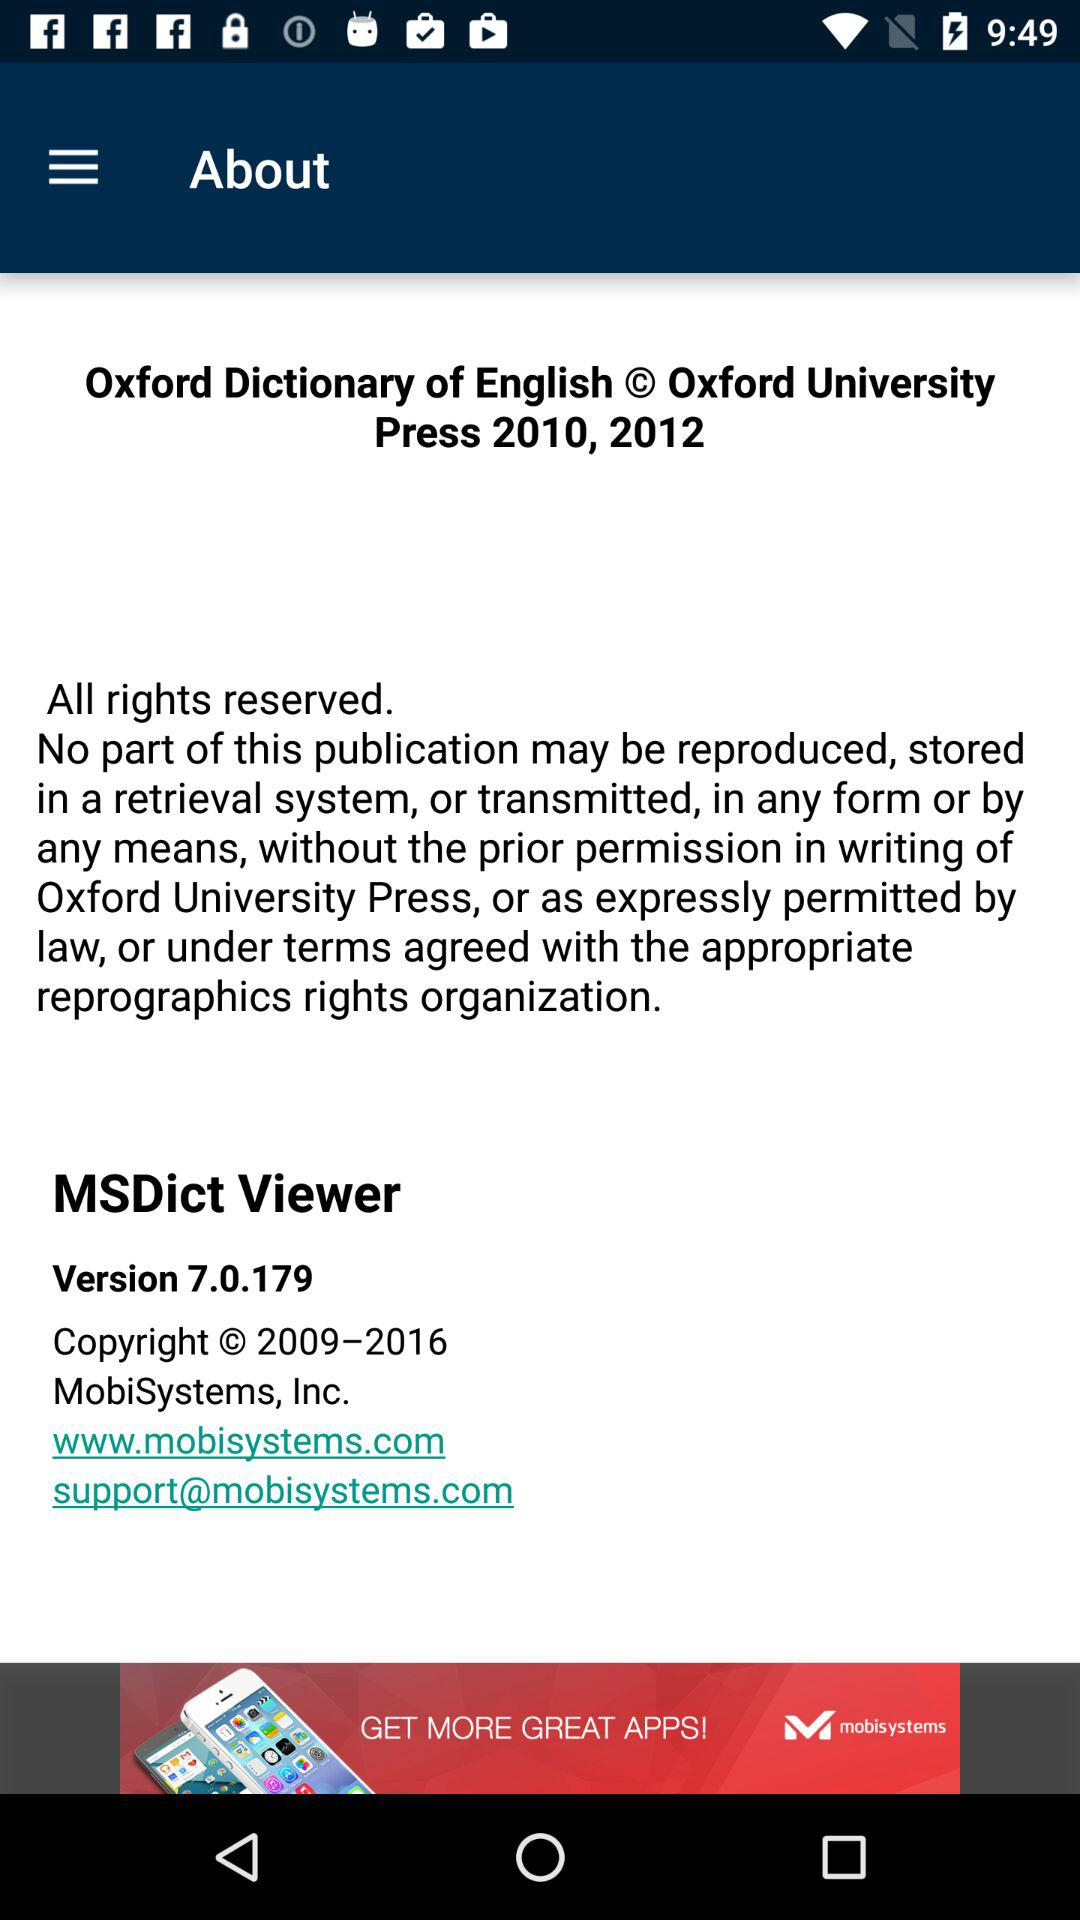What is the version of MSDict Viewer? The version of MSDict Viewer is 7.0.179. 